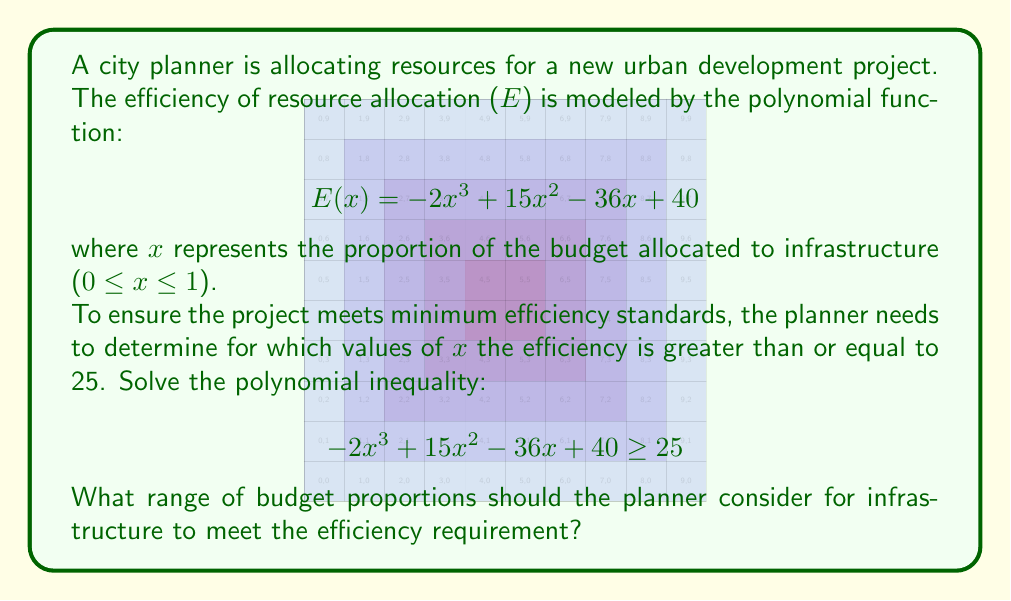Help me with this question. Let's approach this step-by-step:

1) First, we need to rearrange the inequality to standard form:
   $$ -2x^3 + 15x^2 - 36x + 15 \geq 0 $$

2) This is a cubic inequality. To solve it, we need to find the roots of the corresponding equation:
   $$ -2x^3 + 15x^2 - 36x + 15 = 0 $$

3) We can factor this equation:
   $$ -(2x^3 - 15x^2 + 36x - 15) = 0 $$
   $$ -(x-1)(2x^2-13x+15) = 0 $$
   $$ -(x-1)(2x-3)(x-5) = 0 $$

4) The roots are x = 1, x = 3/2, and x = 5

5) Now, we can create a sign chart to determine where the polynomial is non-negative:

   $(-\infty, 1)$: (-)(+)(+)(+) = -
   $(1, 3/2)$: (-)(+)(-)(+) = +
   $(3/2, 5)$: (-)(+)(-)(-)= +
   $(5, \infty)$: (-)(-)(-)(-)= -

6) The inequality is satisfied when the polynomial is non-negative, which occurs in the intervals $[1, 5]$.

7) However, we need to consider the domain constraint 0 ≤ x ≤ 1. This means our final solution is the intersection of $[1, 5]$ and $[0, 1]$, which is simply the point x = 1.
Answer: The planner should allocate 100% of the budget (x = 1) to infrastructure to meet the efficiency requirement while staying within the given constraints. 